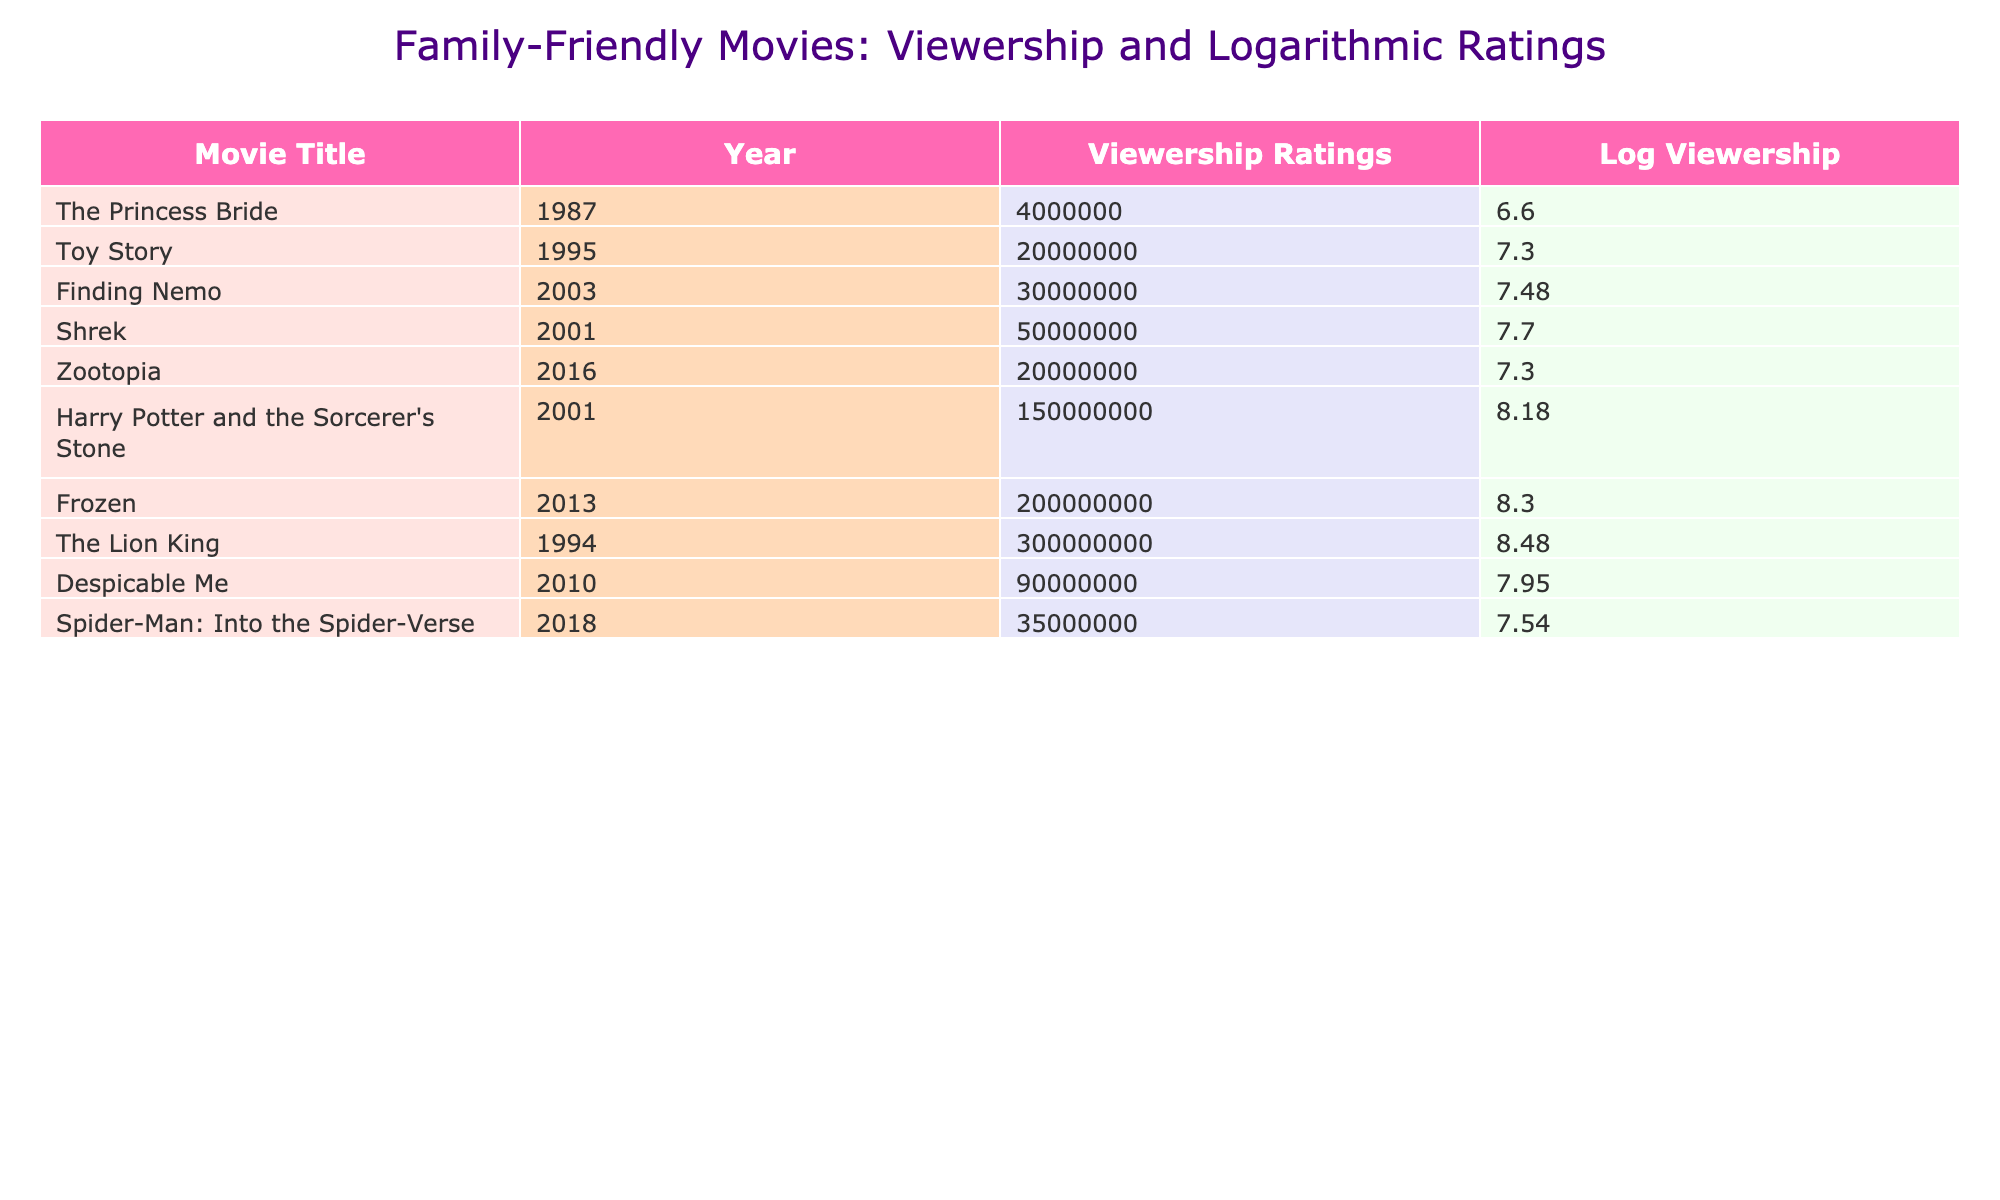What is the viewership rating of "The Lion King"? The viewership rating for "The Lion King" can be found directly in the table, which states it as 300,000,000.
Answer: 300000000 What year was "Finding Nemo" released? According to the table, "Finding Nemo" was released in the year 2003 as indicated in the relevant row.
Answer: 2003 Which movie had the highest viewership ratings? By inspecting the viewership ratings, "Frozen" stands out with the value of 200,000,000, which is the highest rating in the table.
Answer: Frozen Is the viewership rating of "Toy Story" greater than that of "Despicable Me"? The viewership rating for "Toy Story" is 20,000,000 and for "Despicable Me" is 90,000,000. Since 20,000,000 is less than 90,000,000, the statement is false.
Answer: No What is the average viewership rating of the movies from 2000-2010? The viewership ratings for movies from 2000-2010 are 50,000,000 (Shrek), 150,000,000 (Harry Potter), 200,000,000 (Frozen), and 90,000,000 (Despicable Me). Adding these gives 50,000,000 + 150,000,000 + 90,000,000 = 290,000,000. There are 4 movies, so the average is 290,000,000 / 4 = 72,500,000.
Answer: 72500000 What is the difference in viewership ratings between "Harry Potter" and "Zootopia"? "Harry Potter" has 150,000,000 and "Zootopia" has 20,000,000; therefore, the difference can be calculated as 150,000,000 - 20,000,000 = 130,000,000.
Answer: 130000000 Which movie has a log viewership rating greater than 7? To find this, we check the logarithmic values. The log of 300,000,000 (The Lion King) is approximately 8.48, and the log of 200,000,000 (Frozen) is approximately 7.30. Both "The Lion King" and "Frozen" have log values greater than 7.
Answer: The Lion King, Frozen How many movies have a viewership rating of over 50,000,000? Checking the table, the movies are: "Shrek" (50,000,000), "Harry Potter" (150,000,000), "Frozen" (200,000,000), "The Lion King" (300,000,000), and "Despicable Me" (90,000,000). Grouping these, we find 5 movies exceed 50,000,000.
Answer: 5 